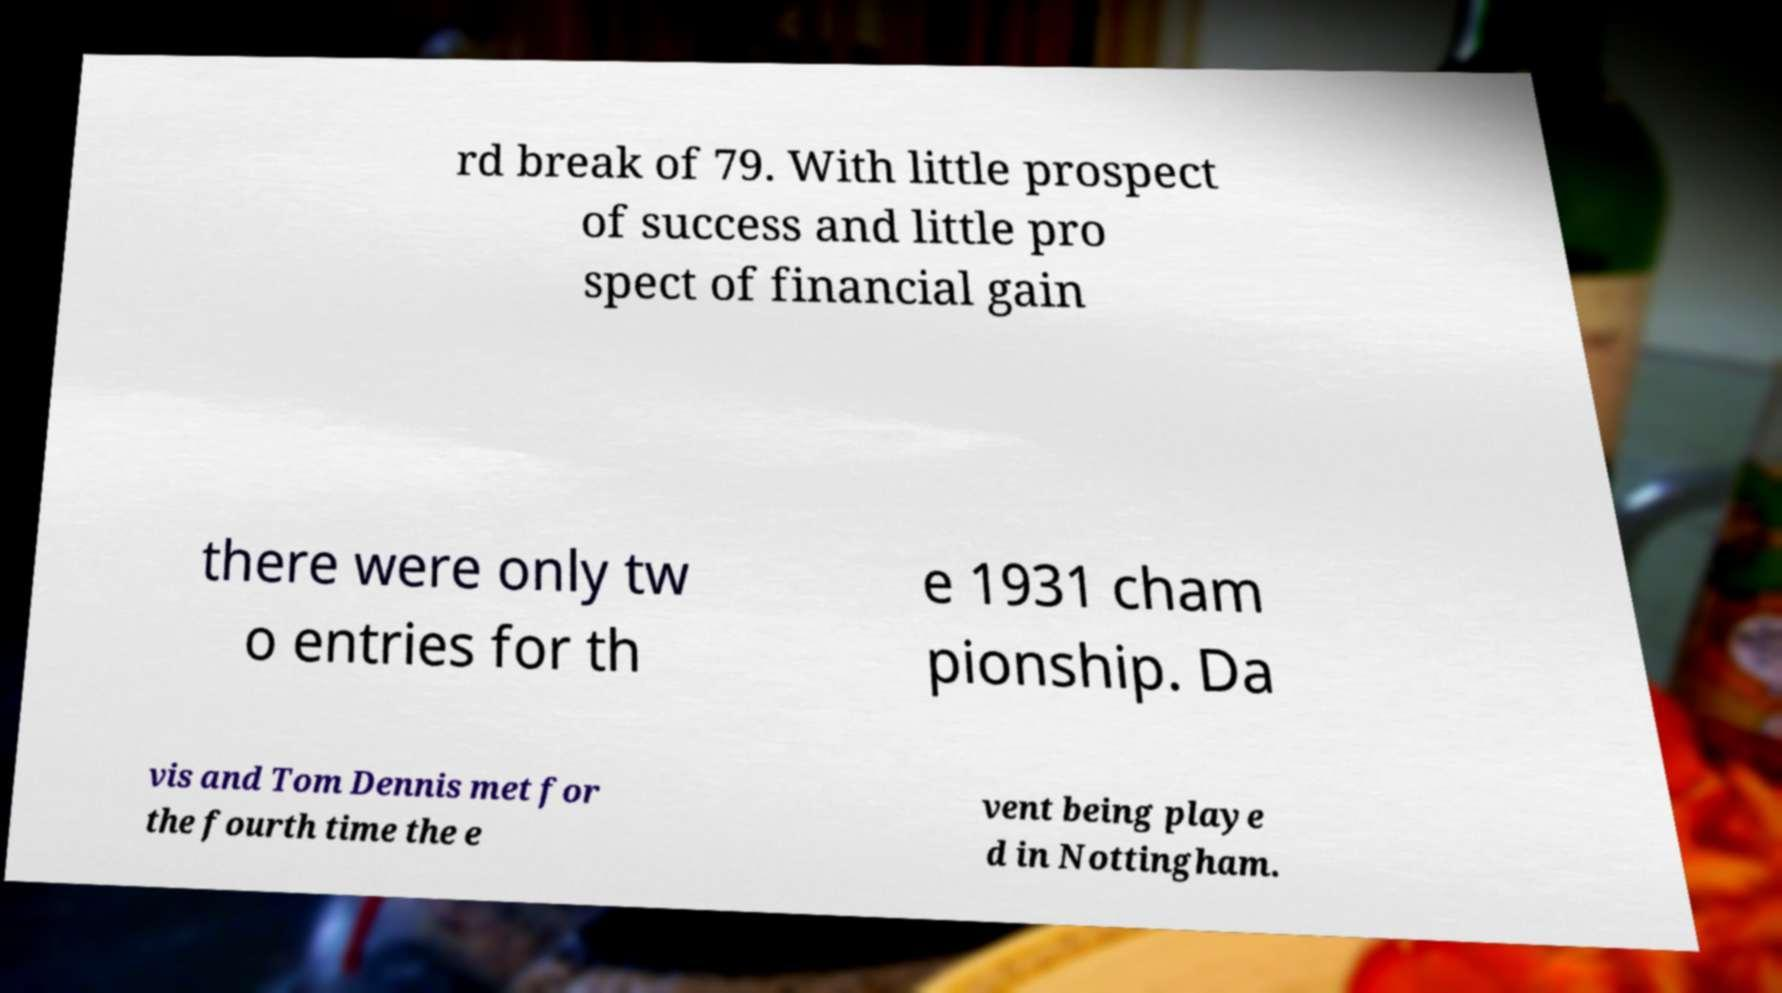Could you assist in decoding the text presented in this image and type it out clearly? rd break of 79. With little prospect of success and little pro spect of financial gain there were only tw o entries for th e 1931 cham pionship. Da vis and Tom Dennis met for the fourth time the e vent being playe d in Nottingham. 